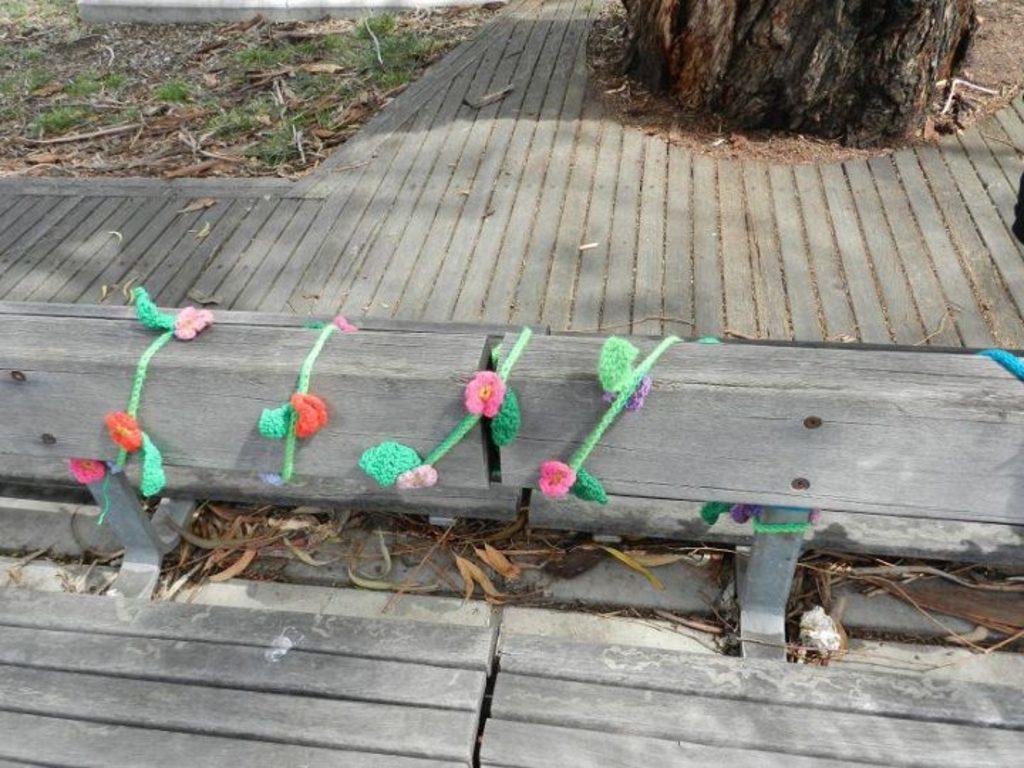Could you give a brief overview of what you see in this image? In the image we can see a wooden log and color rope wounded to it. Here we can see wooden surface, dry grass, grass and the tree trunk. 